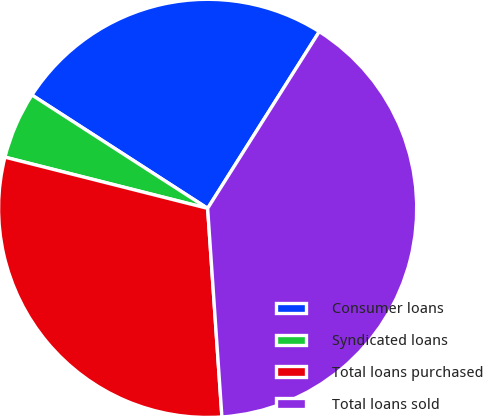Convert chart to OTSL. <chart><loc_0><loc_0><loc_500><loc_500><pie_chart><fcel>Consumer loans<fcel>Syndicated loans<fcel>Total loans purchased<fcel>Total loans sold<nl><fcel>24.85%<fcel>5.18%<fcel>30.03%<fcel>39.95%<nl></chart> 